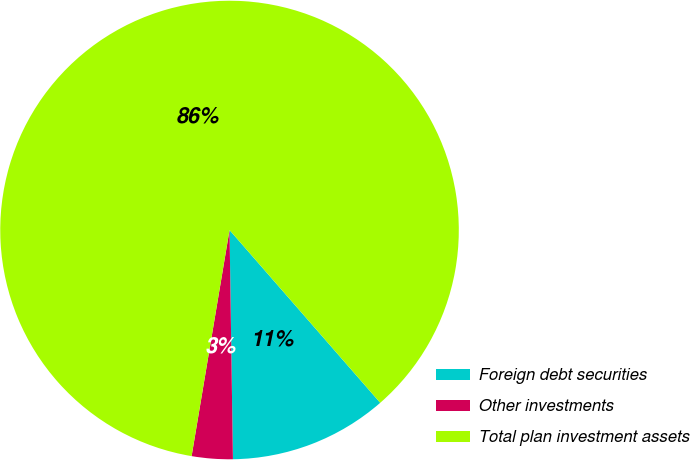Convert chart. <chart><loc_0><loc_0><loc_500><loc_500><pie_chart><fcel>Foreign debt securities<fcel>Other investments<fcel>Total plan investment assets<nl><fcel>11.18%<fcel>2.88%<fcel>85.94%<nl></chart> 